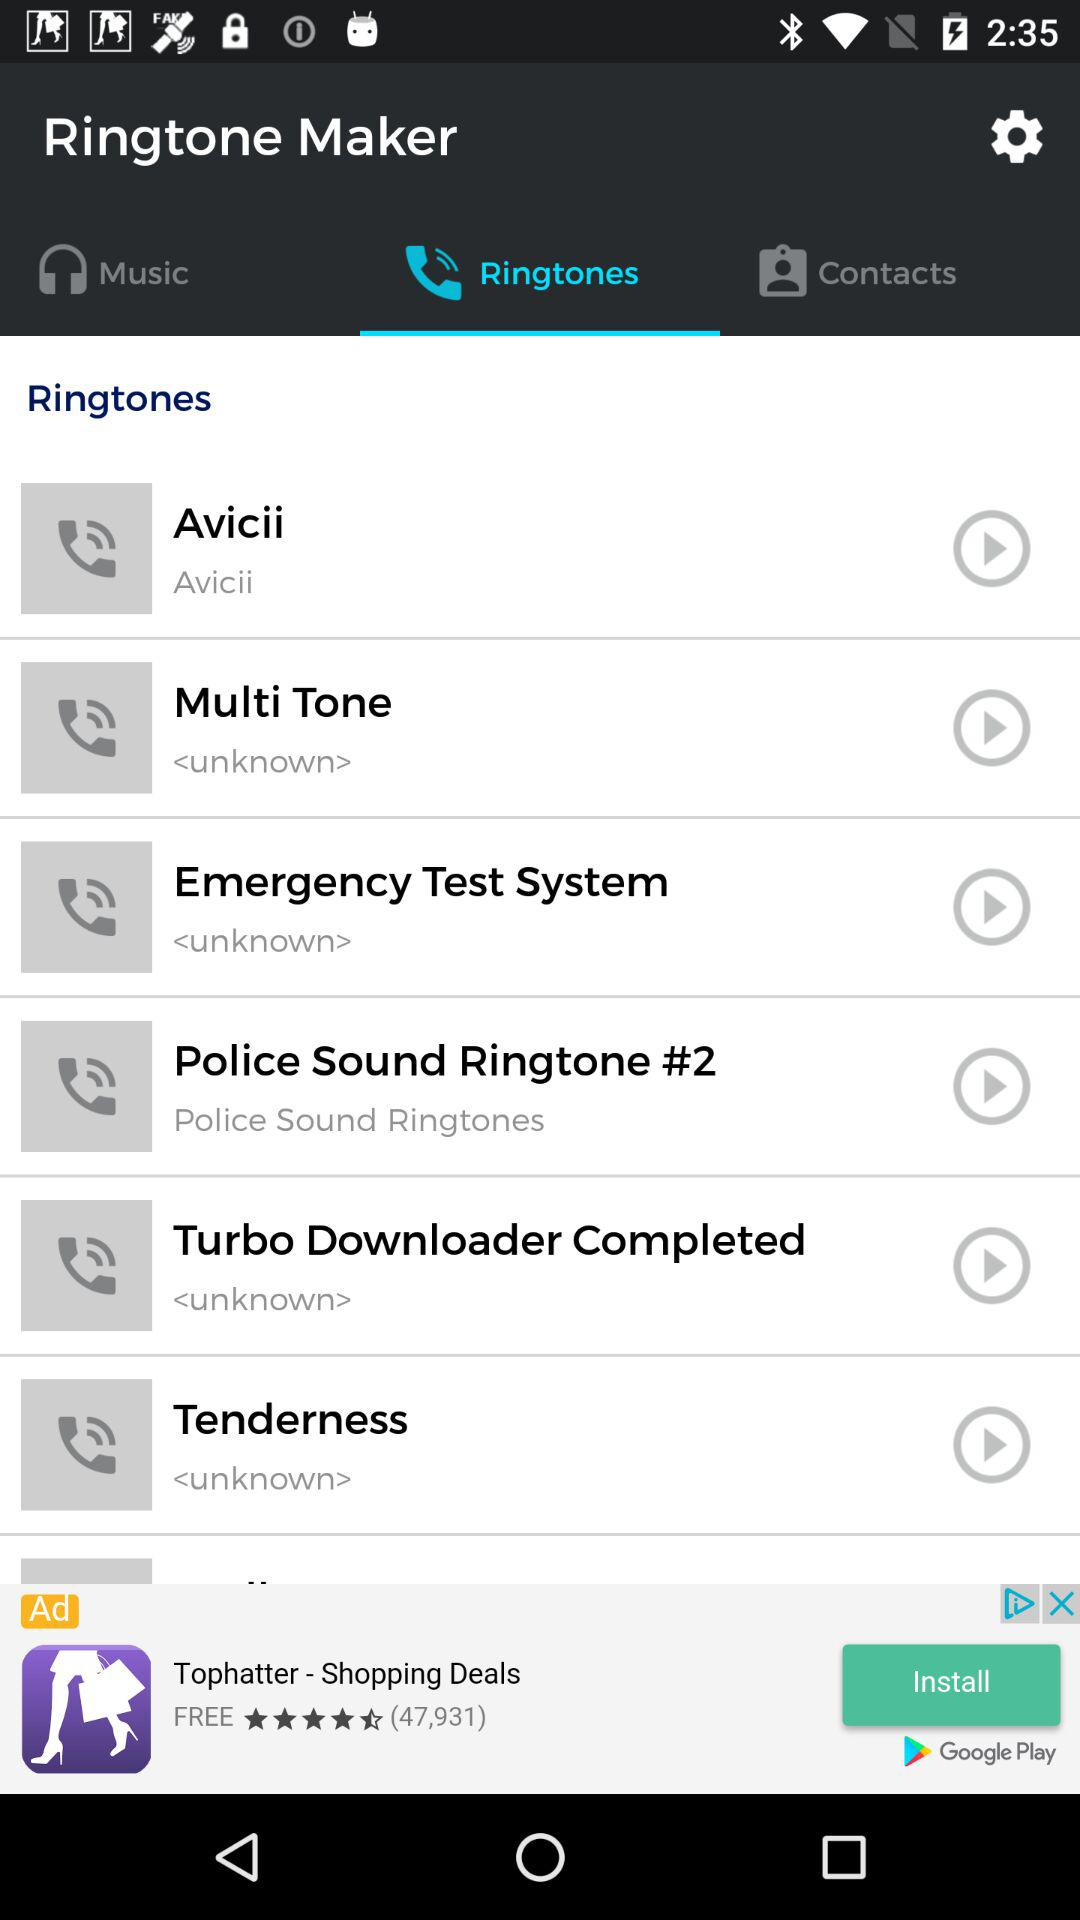What are the options available for "Ringtones"? The available options for ringtones are "Avicii", "Multi Tone", "Emergency Test System", "Police Sound Ringtone #2", "Turbo Downloader Completed" and "Tenderness". 